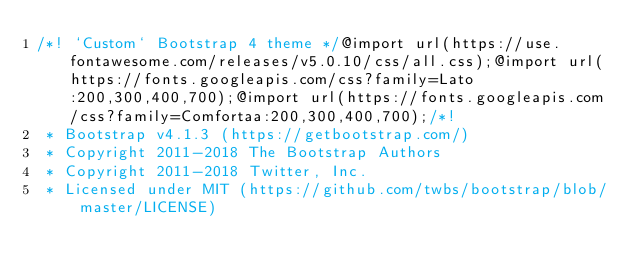<code> <loc_0><loc_0><loc_500><loc_500><_CSS_>/*! `Custom` Bootstrap 4 theme */@import url(https://use.fontawesome.com/releases/v5.0.10/css/all.css);@import url(https://fonts.googleapis.com/css?family=Lato:200,300,400,700);@import url(https://fonts.googleapis.com/css?family=Comfortaa:200,300,400,700);/*!
 * Bootstrap v4.1.3 (https://getbootstrap.com/)
 * Copyright 2011-2018 The Bootstrap Authors
 * Copyright 2011-2018 Twitter, Inc.
 * Licensed under MIT (https://github.com/twbs/bootstrap/blob/master/LICENSE)</code> 